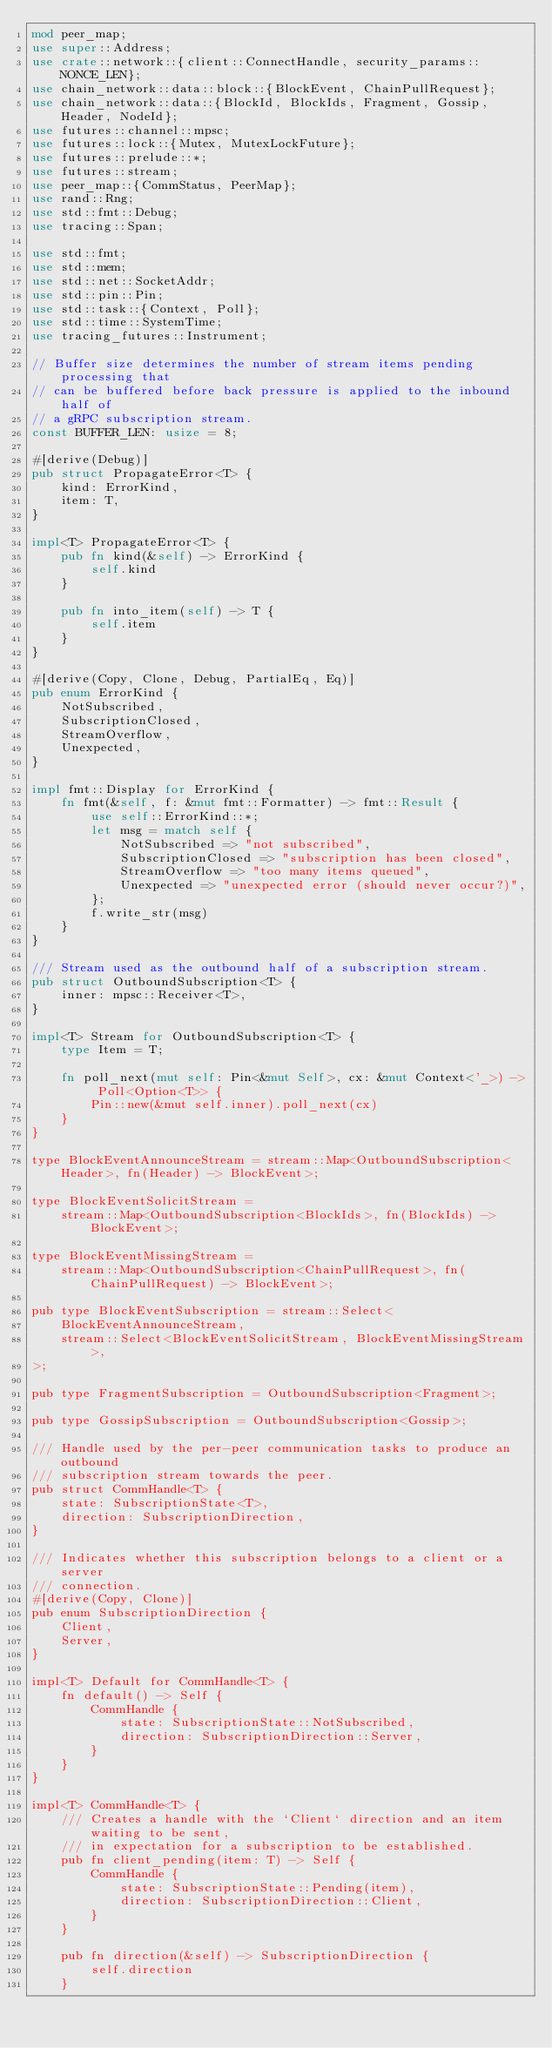<code> <loc_0><loc_0><loc_500><loc_500><_Rust_>mod peer_map;
use super::Address;
use crate::network::{client::ConnectHandle, security_params::NONCE_LEN};
use chain_network::data::block::{BlockEvent, ChainPullRequest};
use chain_network::data::{BlockId, BlockIds, Fragment, Gossip, Header, NodeId};
use futures::channel::mpsc;
use futures::lock::{Mutex, MutexLockFuture};
use futures::prelude::*;
use futures::stream;
use peer_map::{CommStatus, PeerMap};
use rand::Rng;
use std::fmt::Debug;
use tracing::Span;

use std::fmt;
use std::mem;
use std::net::SocketAddr;
use std::pin::Pin;
use std::task::{Context, Poll};
use std::time::SystemTime;
use tracing_futures::Instrument;

// Buffer size determines the number of stream items pending processing that
// can be buffered before back pressure is applied to the inbound half of
// a gRPC subscription stream.
const BUFFER_LEN: usize = 8;

#[derive(Debug)]
pub struct PropagateError<T> {
    kind: ErrorKind,
    item: T,
}

impl<T> PropagateError<T> {
    pub fn kind(&self) -> ErrorKind {
        self.kind
    }

    pub fn into_item(self) -> T {
        self.item
    }
}

#[derive(Copy, Clone, Debug, PartialEq, Eq)]
pub enum ErrorKind {
    NotSubscribed,
    SubscriptionClosed,
    StreamOverflow,
    Unexpected,
}

impl fmt::Display for ErrorKind {
    fn fmt(&self, f: &mut fmt::Formatter) -> fmt::Result {
        use self::ErrorKind::*;
        let msg = match self {
            NotSubscribed => "not subscribed",
            SubscriptionClosed => "subscription has been closed",
            StreamOverflow => "too many items queued",
            Unexpected => "unexpected error (should never occur?)",
        };
        f.write_str(msg)
    }
}

/// Stream used as the outbound half of a subscription stream.
pub struct OutboundSubscription<T> {
    inner: mpsc::Receiver<T>,
}

impl<T> Stream for OutboundSubscription<T> {
    type Item = T;

    fn poll_next(mut self: Pin<&mut Self>, cx: &mut Context<'_>) -> Poll<Option<T>> {
        Pin::new(&mut self.inner).poll_next(cx)
    }
}

type BlockEventAnnounceStream = stream::Map<OutboundSubscription<Header>, fn(Header) -> BlockEvent>;

type BlockEventSolicitStream =
    stream::Map<OutboundSubscription<BlockIds>, fn(BlockIds) -> BlockEvent>;

type BlockEventMissingStream =
    stream::Map<OutboundSubscription<ChainPullRequest>, fn(ChainPullRequest) -> BlockEvent>;

pub type BlockEventSubscription = stream::Select<
    BlockEventAnnounceStream,
    stream::Select<BlockEventSolicitStream, BlockEventMissingStream>,
>;

pub type FragmentSubscription = OutboundSubscription<Fragment>;

pub type GossipSubscription = OutboundSubscription<Gossip>;

/// Handle used by the per-peer communication tasks to produce an outbound
/// subscription stream towards the peer.
pub struct CommHandle<T> {
    state: SubscriptionState<T>,
    direction: SubscriptionDirection,
}

/// Indicates whether this subscription belongs to a client or a server
/// connection.
#[derive(Copy, Clone)]
pub enum SubscriptionDirection {
    Client,
    Server,
}

impl<T> Default for CommHandle<T> {
    fn default() -> Self {
        CommHandle {
            state: SubscriptionState::NotSubscribed,
            direction: SubscriptionDirection::Server,
        }
    }
}

impl<T> CommHandle<T> {
    /// Creates a handle with the `Client` direction and an item waiting to be sent,
    /// in expectation for a subscription to be established.
    pub fn client_pending(item: T) -> Self {
        CommHandle {
            state: SubscriptionState::Pending(item),
            direction: SubscriptionDirection::Client,
        }
    }

    pub fn direction(&self) -> SubscriptionDirection {
        self.direction
    }
</code> 